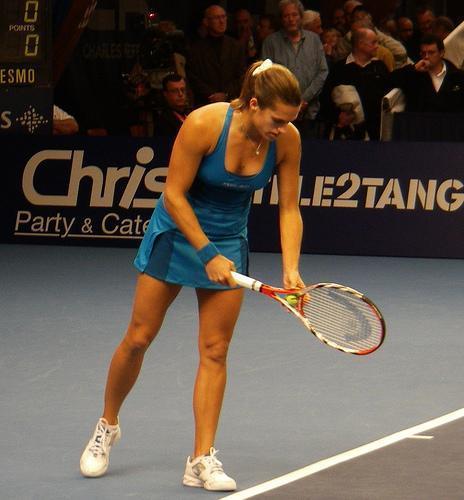How many people on the tennis court?
Give a very brief answer. 1. How many tennis balls in the photo?
Give a very brief answer. 1. 